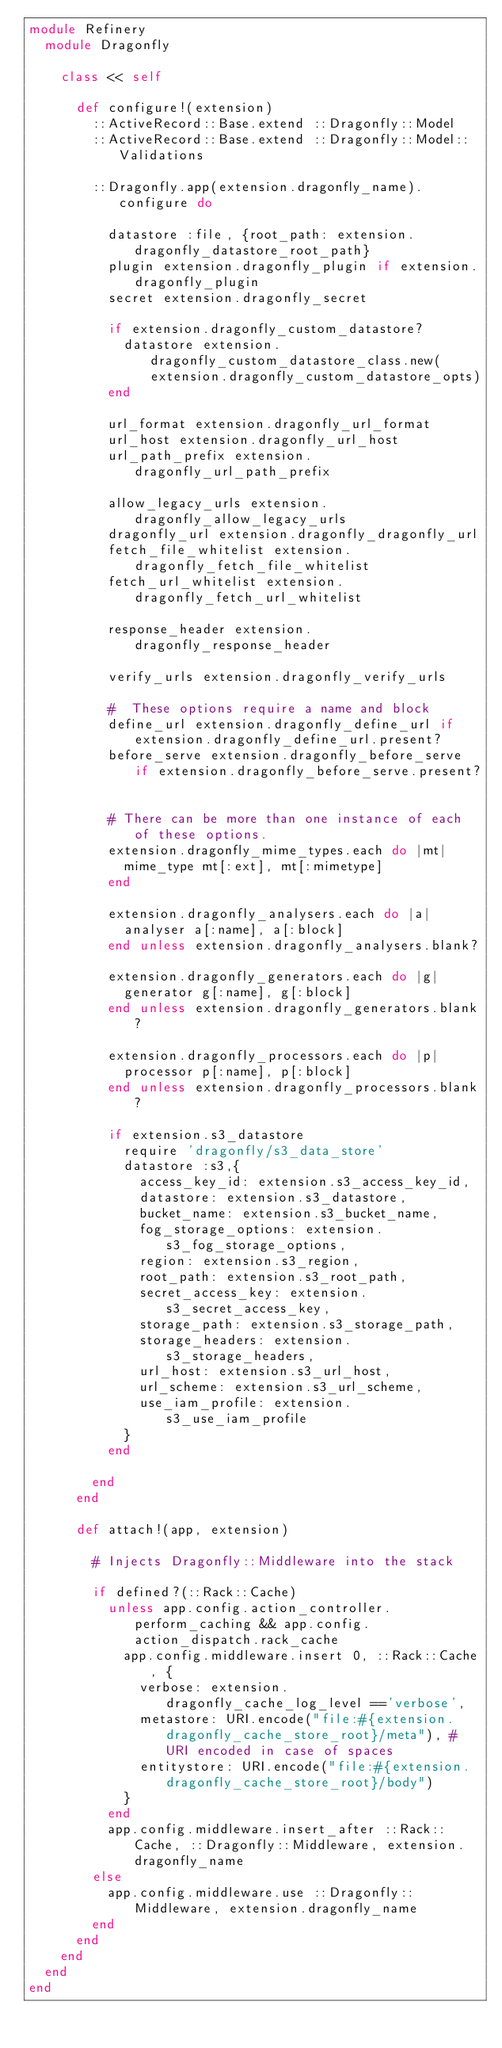Convert code to text. <code><loc_0><loc_0><loc_500><loc_500><_Ruby_>module Refinery
  module Dragonfly

    class << self

      def configure!(extension)
        ::ActiveRecord::Base.extend ::Dragonfly::Model
        ::ActiveRecord::Base.extend ::Dragonfly::Model::Validations

        ::Dragonfly.app(extension.dragonfly_name).configure do

          datastore :file, {root_path: extension.dragonfly_datastore_root_path}
          plugin extension.dragonfly_plugin if extension.dragonfly_plugin
          secret extension.dragonfly_secret

          if extension.dragonfly_custom_datastore?
            datastore extension.dragonfly_custom_datastore_class.new(extension.dragonfly_custom_datastore_opts)
          end

          url_format extension.dragonfly_url_format
          url_host extension.dragonfly_url_host
          url_path_prefix extension.dragonfly_url_path_prefix

          allow_legacy_urls extension.dragonfly_allow_legacy_urls
          dragonfly_url extension.dragonfly_dragonfly_url
          fetch_file_whitelist extension.dragonfly_fetch_file_whitelist
          fetch_url_whitelist extension.dragonfly_fetch_url_whitelist

          response_header extension.dragonfly_response_header

          verify_urls extension.dragonfly_verify_urls

          #  These options require a name and block
          define_url extension.dragonfly_define_url if extension.dragonfly_define_url.present?
          before_serve extension.dragonfly_before_serve if extension.dragonfly_before_serve.present?


          # There can be more than one instance of each of these options.
          extension.dragonfly_mime_types.each do |mt|
            mime_type mt[:ext], mt[:mimetype]
          end

          extension.dragonfly_analysers.each do |a|
            analyser a[:name], a[:block]
          end unless extension.dragonfly_analysers.blank?

          extension.dragonfly_generators.each do |g|
            generator g[:name], g[:block]
          end unless extension.dragonfly_generators.blank?

          extension.dragonfly_processors.each do |p|
            processor p[:name], p[:block]
          end unless extension.dragonfly_processors.blank?

          if extension.s3_datastore
            require 'dragonfly/s3_data_store'
            datastore :s3,{
              access_key_id: extension.s3_access_key_id,
              datastore: extension.s3_datastore,
              bucket_name: extension.s3_bucket_name,
              fog_storage_options: extension.s3_fog_storage_options,
              region: extension.s3_region,
              root_path: extension.s3_root_path,
              secret_access_key: extension.s3_secret_access_key,
              storage_path: extension.s3_storage_path,
              storage_headers: extension.s3_storage_headers,
              url_host: extension.s3_url_host,
              url_scheme: extension.s3_url_scheme,
              use_iam_profile: extension.s3_use_iam_profile
            }
          end

        end
      end

      def attach!(app, extension)

        # Injects Dragonfly::Middleware into the stack

        if defined?(::Rack::Cache)
          unless app.config.action_controller.perform_caching && app.config.action_dispatch.rack_cache
            app.config.middleware.insert 0, ::Rack::Cache, {
              verbose: extension.dragonfly_cache_log_level =='verbose',
              metastore: URI.encode("file:#{extension.dragonfly_cache_store_root}/meta"), # URI encoded in case of spaces
              entitystore: URI.encode("file:#{extension.dragonfly_cache_store_root}/body")
            }
          end
          app.config.middleware.insert_after ::Rack::Cache, ::Dragonfly::Middleware, extension.dragonfly_name
        else
          app.config.middleware.use ::Dragonfly::Middleware, extension.dragonfly_name
        end
      end
    end
  end
end
</code> 